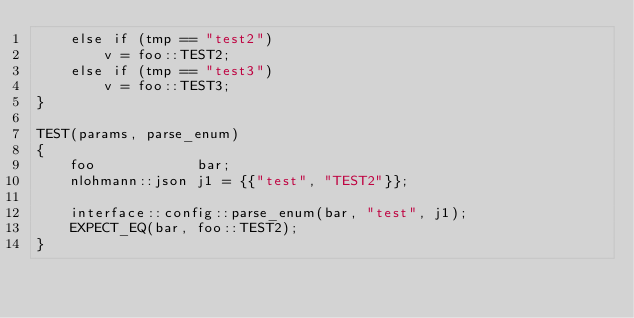<code> <loc_0><loc_0><loc_500><loc_500><_C++_>    else if (tmp == "test2")
        v = foo::TEST2;
    else if (tmp == "test3")
        v = foo::TEST3;
}

TEST(params, parse_enum)
{
    foo            bar;
    nlohmann::json j1 = {{"test", "TEST2"}};

    interface::config::parse_enum(bar, "test", j1);
    EXPECT_EQ(bar, foo::TEST2);
}
</code> 